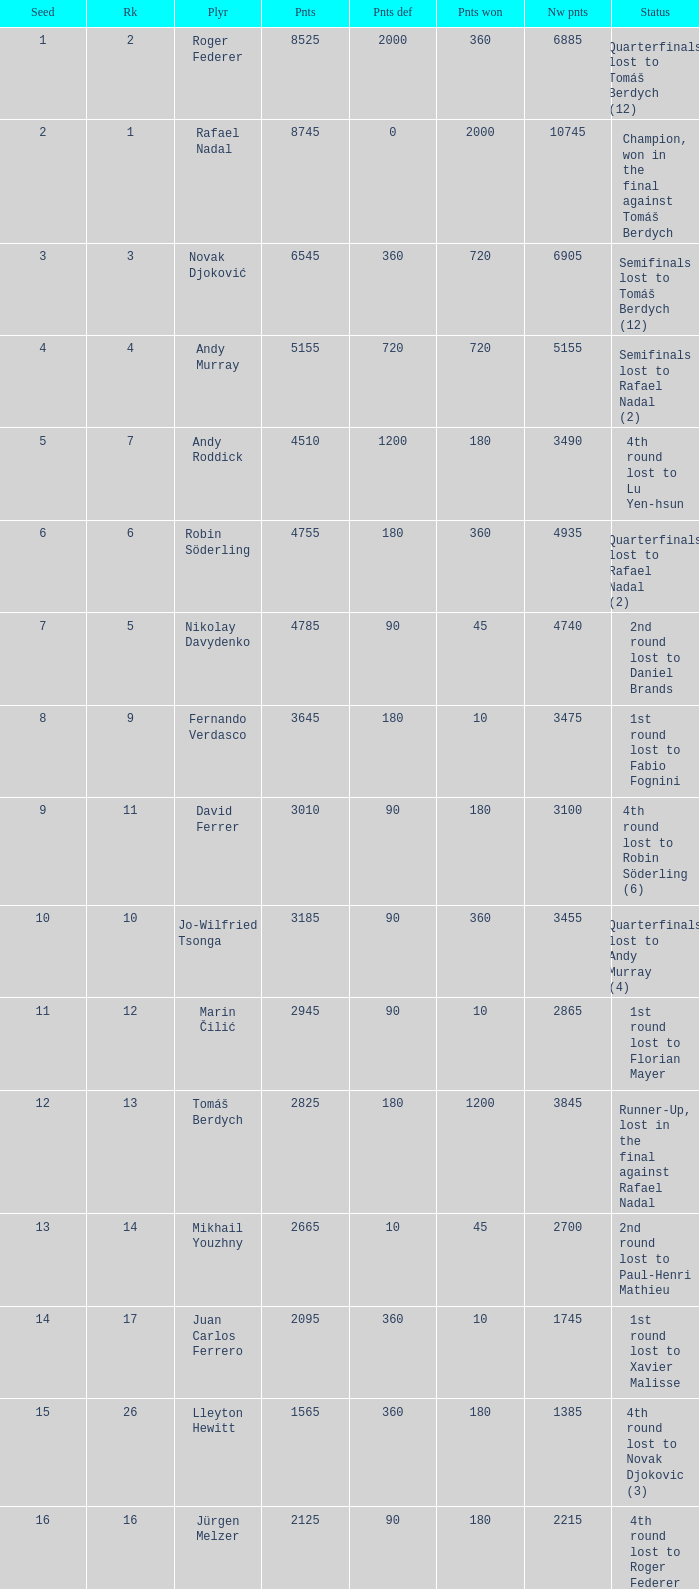Name the points won for 1230 90.0. 